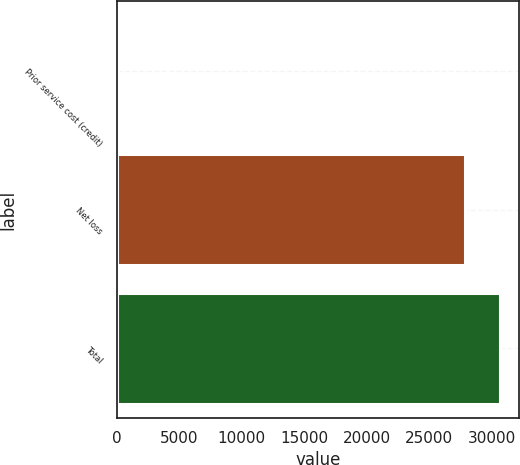<chart> <loc_0><loc_0><loc_500><loc_500><bar_chart><fcel>Prior service cost (credit)<fcel>Net loss<fcel>Total<nl><fcel>110<fcel>27860<fcel>30646<nl></chart> 